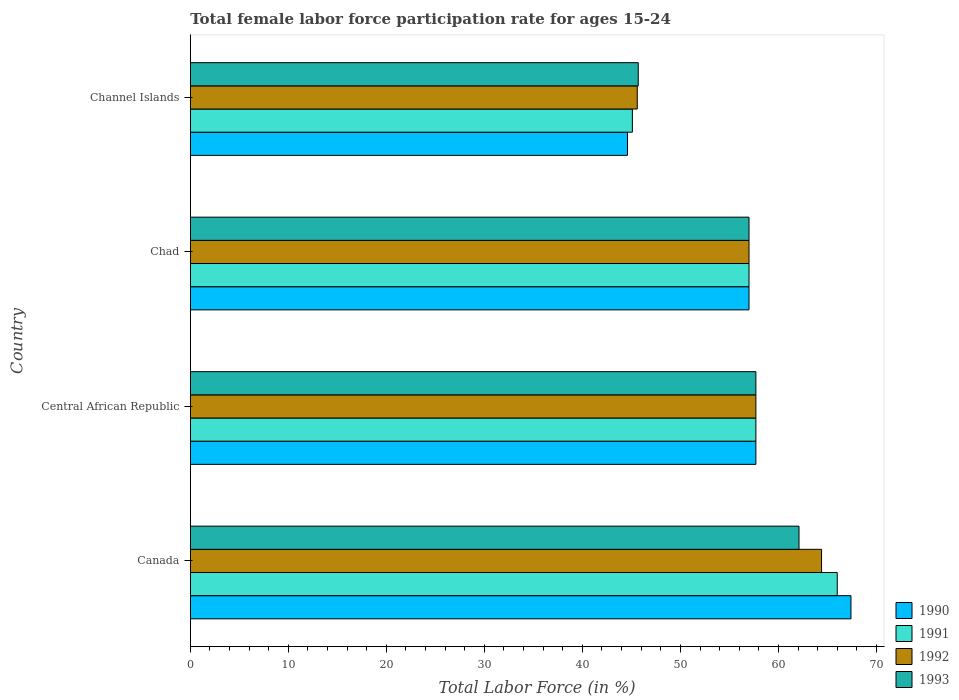How many groups of bars are there?
Provide a short and direct response. 4. Are the number of bars per tick equal to the number of legend labels?
Provide a succinct answer. Yes. How many bars are there on the 2nd tick from the bottom?
Make the answer very short. 4. What is the female labor force participation rate in 1993 in Chad?
Provide a short and direct response. 57. Across all countries, what is the maximum female labor force participation rate in 1993?
Offer a very short reply. 62.1. Across all countries, what is the minimum female labor force participation rate in 1990?
Provide a succinct answer. 44.6. In which country was the female labor force participation rate in 1992 minimum?
Give a very brief answer. Channel Islands. What is the total female labor force participation rate in 1990 in the graph?
Ensure brevity in your answer.  226.7. What is the difference between the female labor force participation rate in 1991 in Central African Republic and that in Chad?
Your response must be concise. 0.7. What is the difference between the female labor force participation rate in 1992 in Chad and the female labor force participation rate in 1991 in Canada?
Your answer should be compact. -9. What is the average female labor force participation rate in 1991 per country?
Provide a succinct answer. 56.45. What is the difference between the female labor force participation rate in 1990 and female labor force participation rate in 1993 in Chad?
Your answer should be very brief. 0. What is the ratio of the female labor force participation rate in 1990 in Central African Republic to that in Channel Islands?
Make the answer very short. 1.29. Is the female labor force participation rate in 1991 in Central African Republic less than that in Chad?
Make the answer very short. No. What is the difference between the highest and the second highest female labor force participation rate in 1991?
Your answer should be compact. 8.3. What is the difference between the highest and the lowest female labor force participation rate in 1991?
Offer a terse response. 20.9. Is the sum of the female labor force participation rate in 1991 in Canada and Channel Islands greater than the maximum female labor force participation rate in 1993 across all countries?
Offer a very short reply. Yes. Is it the case that in every country, the sum of the female labor force participation rate in 1990 and female labor force participation rate in 1992 is greater than the female labor force participation rate in 1993?
Provide a short and direct response. Yes. Are all the bars in the graph horizontal?
Give a very brief answer. Yes. Does the graph contain any zero values?
Provide a succinct answer. No. How many legend labels are there?
Keep it short and to the point. 4. What is the title of the graph?
Offer a very short reply. Total female labor force participation rate for ages 15-24. What is the label or title of the X-axis?
Provide a short and direct response. Total Labor Force (in %). What is the label or title of the Y-axis?
Give a very brief answer. Country. What is the Total Labor Force (in %) of 1990 in Canada?
Give a very brief answer. 67.4. What is the Total Labor Force (in %) of 1991 in Canada?
Ensure brevity in your answer.  66. What is the Total Labor Force (in %) of 1992 in Canada?
Your answer should be compact. 64.4. What is the Total Labor Force (in %) in 1993 in Canada?
Your answer should be compact. 62.1. What is the Total Labor Force (in %) of 1990 in Central African Republic?
Ensure brevity in your answer.  57.7. What is the Total Labor Force (in %) in 1991 in Central African Republic?
Offer a very short reply. 57.7. What is the Total Labor Force (in %) in 1992 in Central African Republic?
Keep it short and to the point. 57.7. What is the Total Labor Force (in %) in 1993 in Central African Republic?
Your response must be concise. 57.7. What is the Total Labor Force (in %) in 1990 in Chad?
Offer a very short reply. 57. What is the Total Labor Force (in %) of 1991 in Chad?
Your answer should be very brief. 57. What is the Total Labor Force (in %) of 1992 in Chad?
Give a very brief answer. 57. What is the Total Labor Force (in %) in 1990 in Channel Islands?
Offer a terse response. 44.6. What is the Total Labor Force (in %) of 1991 in Channel Islands?
Your response must be concise. 45.1. What is the Total Labor Force (in %) in 1992 in Channel Islands?
Your answer should be compact. 45.6. What is the Total Labor Force (in %) in 1993 in Channel Islands?
Your response must be concise. 45.7. Across all countries, what is the maximum Total Labor Force (in %) of 1990?
Your response must be concise. 67.4. Across all countries, what is the maximum Total Labor Force (in %) in 1991?
Offer a terse response. 66. Across all countries, what is the maximum Total Labor Force (in %) of 1992?
Make the answer very short. 64.4. Across all countries, what is the maximum Total Labor Force (in %) in 1993?
Ensure brevity in your answer.  62.1. Across all countries, what is the minimum Total Labor Force (in %) of 1990?
Keep it short and to the point. 44.6. Across all countries, what is the minimum Total Labor Force (in %) in 1991?
Your answer should be very brief. 45.1. Across all countries, what is the minimum Total Labor Force (in %) in 1992?
Offer a very short reply. 45.6. Across all countries, what is the minimum Total Labor Force (in %) of 1993?
Offer a terse response. 45.7. What is the total Total Labor Force (in %) of 1990 in the graph?
Offer a very short reply. 226.7. What is the total Total Labor Force (in %) of 1991 in the graph?
Offer a very short reply. 225.8. What is the total Total Labor Force (in %) in 1992 in the graph?
Provide a short and direct response. 224.7. What is the total Total Labor Force (in %) in 1993 in the graph?
Your response must be concise. 222.5. What is the difference between the Total Labor Force (in %) of 1991 in Canada and that in Central African Republic?
Offer a terse response. 8.3. What is the difference between the Total Labor Force (in %) in 1993 in Canada and that in Central African Republic?
Your response must be concise. 4.4. What is the difference between the Total Labor Force (in %) in 1990 in Canada and that in Channel Islands?
Give a very brief answer. 22.8. What is the difference between the Total Labor Force (in %) in 1991 in Canada and that in Channel Islands?
Provide a succinct answer. 20.9. What is the difference between the Total Labor Force (in %) in 1991 in Central African Republic and that in Chad?
Offer a very short reply. 0.7. What is the difference between the Total Labor Force (in %) in 1992 in Central African Republic and that in Chad?
Offer a terse response. 0.7. What is the difference between the Total Labor Force (in %) in 1990 in Chad and that in Channel Islands?
Your response must be concise. 12.4. What is the difference between the Total Labor Force (in %) in 1990 in Canada and the Total Labor Force (in %) in 1991 in Central African Republic?
Give a very brief answer. 9.7. What is the difference between the Total Labor Force (in %) in 1990 in Canada and the Total Labor Force (in %) in 1993 in Central African Republic?
Your response must be concise. 9.7. What is the difference between the Total Labor Force (in %) in 1992 in Canada and the Total Labor Force (in %) in 1993 in Central African Republic?
Ensure brevity in your answer.  6.7. What is the difference between the Total Labor Force (in %) in 1991 in Canada and the Total Labor Force (in %) in 1992 in Chad?
Make the answer very short. 9. What is the difference between the Total Labor Force (in %) in 1990 in Canada and the Total Labor Force (in %) in 1991 in Channel Islands?
Make the answer very short. 22.3. What is the difference between the Total Labor Force (in %) in 1990 in Canada and the Total Labor Force (in %) in 1992 in Channel Islands?
Your answer should be compact. 21.8. What is the difference between the Total Labor Force (in %) of 1990 in Canada and the Total Labor Force (in %) of 1993 in Channel Islands?
Offer a very short reply. 21.7. What is the difference between the Total Labor Force (in %) of 1991 in Canada and the Total Labor Force (in %) of 1992 in Channel Islands?
Provide a short and direct response. 20.4. What is the difference between the Total Labor Force (in %) of 1991 in Canada and the Total Labor Force (in %) of 1993 in Channel Islands?
Make the answer very short. 20.3. What is the difference between the Total Labor Force (in %) in 1992 in Canada and the Total Labor Force (in %) in 1993 in Channel Islands?
Provide a short and direct response. 18.7. What is the difference between the Total Labor Force (in %) of 1990 in Central African Republic and the Total Labor Force (in %) of 1991 in Chad?
Provide a short and direct response. 0.7. What is the difference between the Total Labor Force (in %) of 1990 in Central African Republic and the Total Labor Force (in %) of 1992 in Chad?
Ensure brevity in your answer.  0.7. What is the difference between the Total Labor Force (in %) in 1991 in Central African Republic and the Total Labor Force (in %) in 1992 in Chad?
Give a very brief answer. 0.7. What is the difference between the Total Labor Force (in %) of 1991 in Central African Republic and the Total Labor Force (in %) of 1993 in Chad?
Offer a very short reply. 0.7. What is the difference between the Total Labor Force (in %) of 1991 in Central African Republic and the Total Labor Force (in %) of 1992 in Channel Islands?
Provide a succinct answer. 12.1. What is the difference between the Total Labor Force (in %) in 1991 in Central African Republic and the Total Labor Force (in %) in 1993 in Channel Islands?
Your answer should be very brief. 12. What is the difference between the Total Labor Force (in %) in 1992 in Central African Republic and the Total Labor Force (in %) in 1993 in Channel Islands?
Offer a terse response. 12. What is the difference between the Total Labor Force (in %) in 1990 in Chad and the Total Labor Force (in %) in 1991 in Channel Islands?
Make the answer very short. 11.9. What is the difference between the Total Labor Force (in %) in 1990 in Chad and the Total Labor Force (in %) in 1992 in Channel Islands?
Provide a short and direct response. 11.4. What is the difference between the Total Labor Force (in %) in 1992 in Chad and the Total Labor Force (in %) in 1993 in Channel Islands?
Keep it short and to the point. 11.3. What is the average Total Labor Force (in %) of 1990 per country?
Your response must be concise. 56.67. What is the average Total Labor Force (in %) of 1991 per country?
Offer a terse response. 56.45. What is the average Total Labor Force (in %) of 1992 per country?
Your answer should be compact. 56.17. What is the average Total Labor Force (in %) in 1993 per country?
Offer a terse response. 55.62. What is the difference between the Total Labor Force (in %) in 1990 and Total Labor Force (in %) in 1991 in Canada?
Keep it short and to the point. 1.4. What is the difference between the Total Labor Force (in %) of 1990 and Total Labor Force (in %) of 1993 in Canada?
Provide a short and direct response. 5.3. What is the difference between the Total Labor Force (in %) in 1991 and Total Labor Force (in %) in 1993 in Canada?
Your answer should be very brief. 3.9. What is the difference between the Total Labor Force (in %) in 1990 and Total Labor Force (in %) in 1993 in Central African Republic?
Your answer should be compact. 0. What is the difference between the Total Labor Force (in %) of 1991 and Total Labor Force (in %) of 1993 in Central African Republic?
Make the answer very short. 0. What is the difference between the Total Labor Force (in %) of 1992 and Total Labor Force (in %) of 1993 in Central African Republic?
Keep it short and to the point. 0. What is the difference between the Total Labor Force (in %) of 1990 and Total Labor Force (in %) of 1991 in Chad?
Provide a succinct answer. 0. What is the difference between the Total Labor Force (in %) in 1990 and Total Labor Force (in %) in 1992 in Chad?
Provide a succinct answer. 0. What is the difference between the Total Labor Force (in %) in 1990 and Total Labor Force (in %) in 1993 in Chad?
Provide a short and direct response. 0. What is the difference between the Total Labor Force (in %) in 1991 and Total Labor Force (in %) in 1992 in Chad?
Your response must be concise. 0. What is the difference between the Total Labor Force (in %) in 1991 and Total Labor Force (in %) in 1993 in Chad?
Make the answer very short. 0. What is the difference between the Total Labor Force (in %) in 1990 and Total Labor Force (in %) in 1992 in Channel Islands?
Provide a succinct answer. -1. What is the difference between the Total Labor Force (in %) in 1991 and Total Labor Force (in %) in 1992 in Channel Islands?
Offer a very short reply. -0.5. What is the difference between the Total Labor Force (in %) of 1991 and Total Labor Force (in %) of 1993 in Channel Islands?
Give a very brief answer. -0.6. What is the difference between the Total Labor Force (in %) of 1992 and Total Labor Force (in %) of 1993 in Channel Islands?
Make the answer very short. -0.1. What is the ratio of the Total Labor Force (in %) in 1990 in Canada to that in Central African Republic?
Keep it short and to the point. 1.17. What is the ratio of the Total Labor Force (in %) in 1991 in Canada to that in Central African Republic?
Provide a short and direct response. 1.14. What is the ratio of the Total Labor Force (in %) in 1992 in Canada to that in Central African Republic?
Offer a very short reply. 1.12. What is the ratio of the Total Labor Force (in %) in 1993 in Canada to that in Central African Republic?
Offer a terse response. 1.08. What is the ratio of the Total Labor Force (in %) in 1990 in Canada to that in Chad?
Keep it short and to the point. 1.18. What is the ratio of the Total Labor Force (in %) in 1991 in Canada to that in Chad?
Your response must be concise. 1.16. What is the ratio of the Total Labor Force (in %) in 1992 in Canada to that in Chad?
Make the answer very short. 1.13. What is the ratio of the Total Labor Force (in %) in 1993 in Canada to that in Chad?
Make the answer very short. 1.09. What is the ratio of the Total Labor Force (in %) of 1990 in Canada to that in Channel Islands?
Your response must be concise. 1.51. What is the ratio of the Total Labor Force (in %) in 1991 in Canada to that in Channel Islands?
Give a very brief answer. 1.46. What is the ratio of the Total Labor Force (in %) of 1992 in Canada to that in Channel Islands?
Your answer should be compact. 1.41. What is the ratio of the Total Labor Force (in %) in 1993 in Canada to that in Channel Islands?
Provide a short and direct response. 1.36. What is the ratio of the Total Labor Force (in %) of 1990 in Central African Republic to that in Chad?
Ensure brevity in your answer.  1.01. What is the ratio of the Total Labor Force (in %) of 1991 in Central African Republic to that in Chad?
Your answer should be very brief. 1.01. What is the ratio of the Total Labor Force (in %) in 1992 in Central African Republic to that in Chad?
Your answer should be very brief. 1.01. What is the ratio of the Total Labor Force (in %) in 1993 in Central African Republic to that in Chad?
Offer a very short reply. 1.01. What is the ratio of the Total Labor Force (in %) of 1990 in Central African Republic to that in Channel Islands?
Give a very brief answer. 1.29. What is the ratio of the Total Labor Force (in %) in 1991 in Central African Republic to that in Channel Islands?
Your response must be concise. 1.28. What is the ratio of the Total Labor Force (in %) in 1992 in Central African Republic to that in Channel Islands?
Provide a short and direct response. 1.27. What is the ratio of the Total Labor Force (in %) of 1993 in Central African Republic to that in Channel Islands?
Your answer should be compact. 1.26. What is the ratio of the Total Labor Force (in %) of 1990 in Chad to that in Channel Islands?
Provide a short and direct response. 1.28. What is the ratio of the Total Labor Force (in %) in 1991 in Chad to that in Channel Islands?
Offer a very short reply. 1.26. What is the ratio of the Total Labor Force (in %) of 1993 in Chad to that in Channel Islands?
Offer a terse response. 1.25. What is the difference between the highest and the second highest Total Labor Force (in %) of 1991?
Give a very brief answer. 8.3. What is the difference between the highest and the second highest Total Labor Force (in %) in 1992?
Provide a succinct answer. 6.7. What is the difference between the highest and the second highest Total Labor Force (in %) in 1993?
Offer a very short reply. 4.4. What is the difference between the highest and the lowest Total Labor Force (in %) of 1990?
Provide a short and direct response. 22.8. What is the difference between the highest and the lowest Total Labor Force (in %) of 1991?
Provide a short and direct response. 20.9. What is the difference between the highest and the lowest Total Labor Force (in %) of 1992?
Make the answer very short. 18.8. What is the difference between the highest and the lowest Total Labor Force (in %) in 1993?
Offer a very short reply. 16.4. 